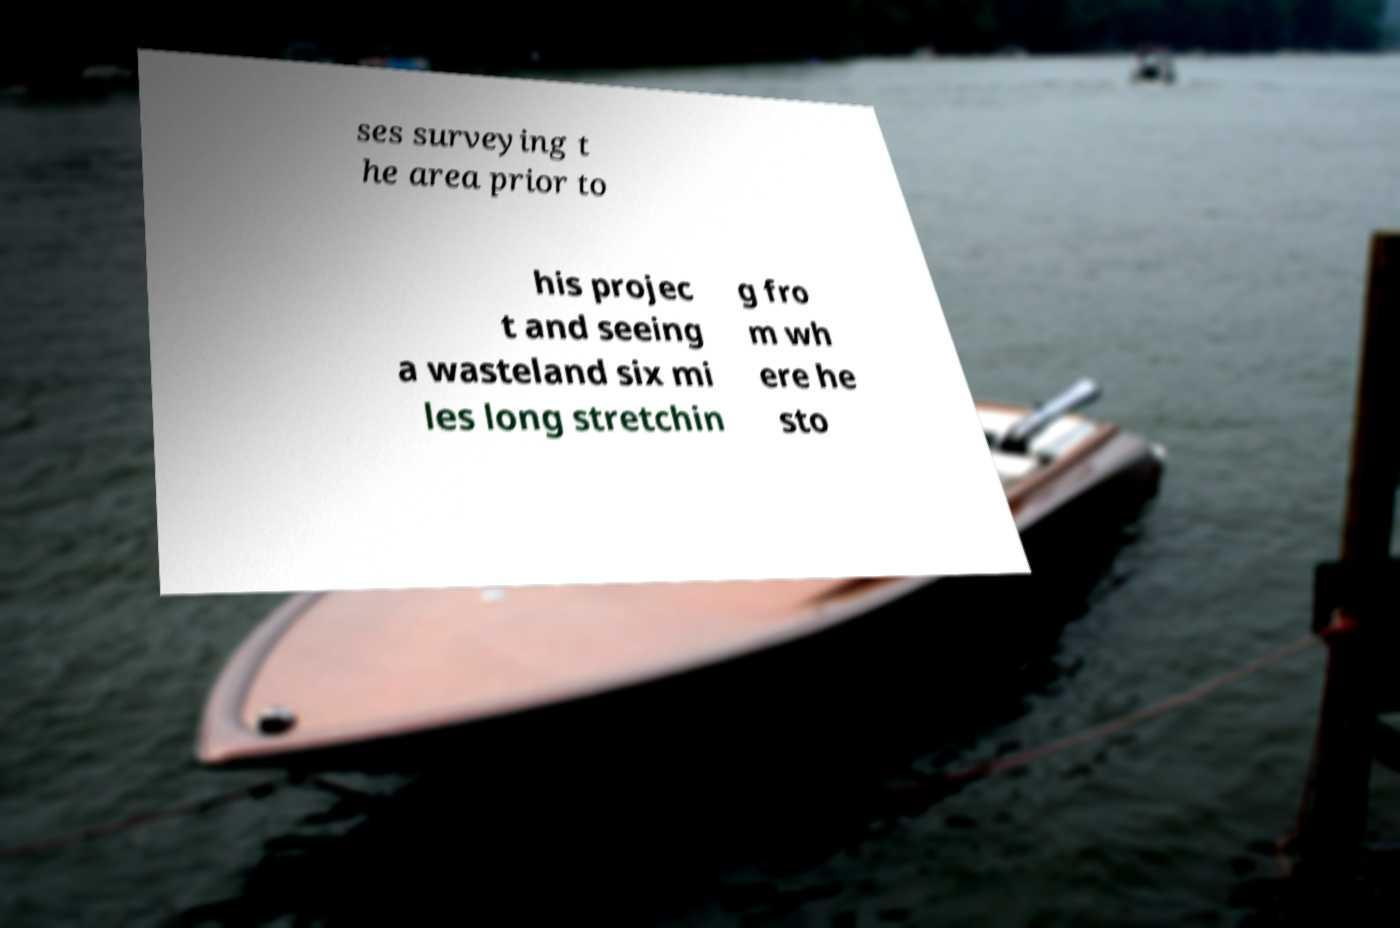What messages or text are displayed in this image? I need them in a readable, typed format. ses surveying t he area prior to his projec t and seeing a wasteland six mi les long stretchin g fro m wh ere he sto 